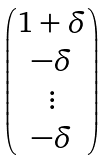<formula> <loc_0><loc_0><loc_500><loc_500>\begin{pmatrix} 1 + \delta \\ - \delta \\ \vdots \\ - \delta \end{pmatrix}</formula> 